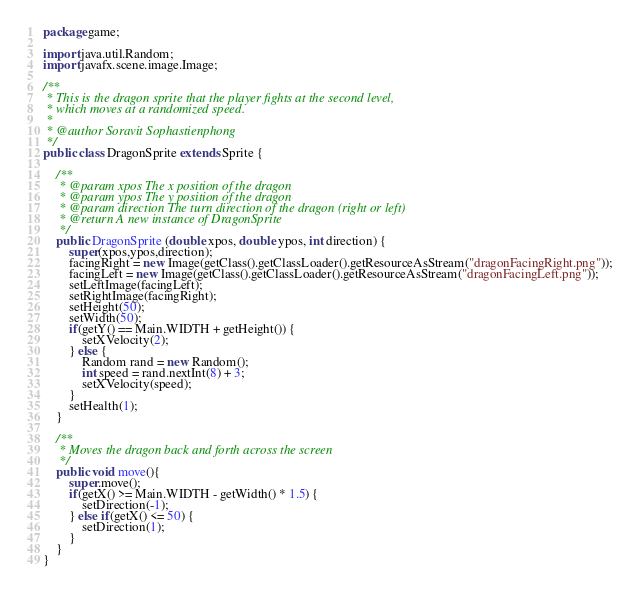Convert code to text. <code><loc_0><loc_0><loc_500><loc_500><_Java_>package game;

import java.util.Random;
import javafx.scene.image.Image;

/**
 * This is the dragon sprite that the player fights at the second level, 
 * which moves at a randomized speed.
 * 
 * @author Soravit Sophastienphong
 */
public class DragonSprite extends Sprite {

    /**
     * @param xpos The x position of the dragon
     * @param ypos The y position of the dragon
     * @param direction The turn direction of the dragon (right or left)
     * @return A new instance of DragonSprite
     */
    public DragonSprite (double xpos, double ypos, int direction) {
        super(xpos,ypos,direction);
        facingRight = new Image(getClass().getClassLoader().getResourceAsStream("dragonFacingRight.png"));
        facingLeft = new Image(getClass().getClassLoader().getResourceAsStream("dragonFacingLeft.png"));
        setLeftImage(facingLeft);
        setRightImage(facingRight);
        setHeight(50);
        setWidth(50);
        if(getY() == Main.WIDTH + getHeight()) {
            setXVelocity(2);
        } else {
            Random rand = new Random();
            int speed = rand.nextInt(8) + 3;
            setXVelocity(speed);
        }
        setHealth(1);
    }

    /**
     * Moves the dragon back and forth across the screen
     */
    public void move(){
        super.move();
        if(getX() >= Main.WIDTH - getWidth() * 1.5) {
            setDirection(-1);
        } else if(getX() <= 50) {
            setDirection(1);
        }
    }
}</code> 